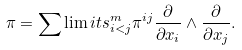Convert formula to latex. <formula><loc_0><loc_0><loc_500><loc_500>\pi = \sum \lim i t s _ { i < j } ^ { m } \pi ^ { i j } \frac { \partial } { \partial x _ { i } } \wedge \frac { \partial } { \partial x _ { j } } .</formula> 